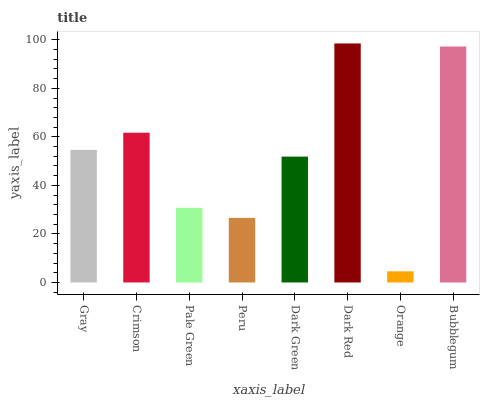Is Orange the minimum?
Answer yes or no. Yes. Is Dark Red the maximum?
Answer yes or no. Yes. Is Crimson the minimum?
Answer yes or no. No. Is Crimson the maximum?
Answer yes or no. No. Is Crimson greater than Gray?
Answer yes or no. Yes. Is Gray less than Crimson?
Answer yes or no. Yes. Is Gray greater than Crimson?
Answer yes or no. No. Is Crimson less than Gray?
Answer yes or no. No. Is Gray the high median?
Answer yes or no. Yes. Is Dark Green the low median?
Answer yes or no. Yes. Is Bubblegum the high median?
Answer yes or no. No. Is Peru the low median?
Answer yes or no. No. 